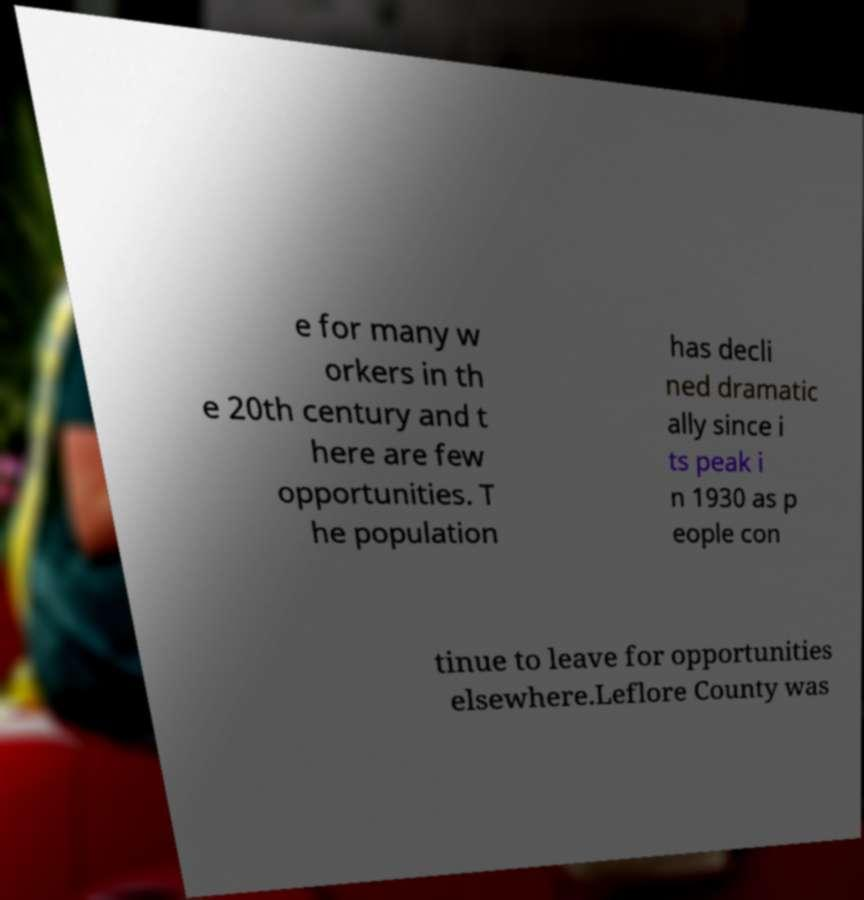There's text embedded in this image that I need extracted. Can you transcribe it verbatim? e for many w orkers in th e 20th century and t here are few opportunities. T he population has decli ned dramatic ally since i ts peak i n 1930 as p eople con tinue to leave for opportunities elsewhere.Leflore County was 